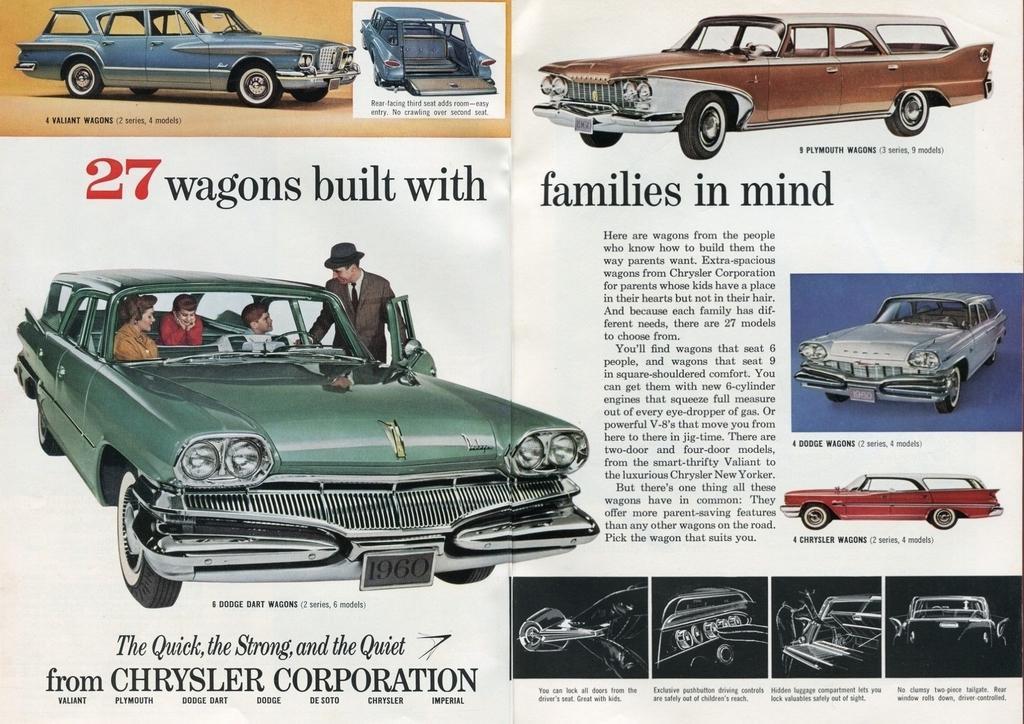Please provide a concise description of this image. In this picture, we see a poster containing the images of cars in different colors. These cars are in green, blue, red and maroon color. We see three people are sitting in the car. We even see text written on the poster. 